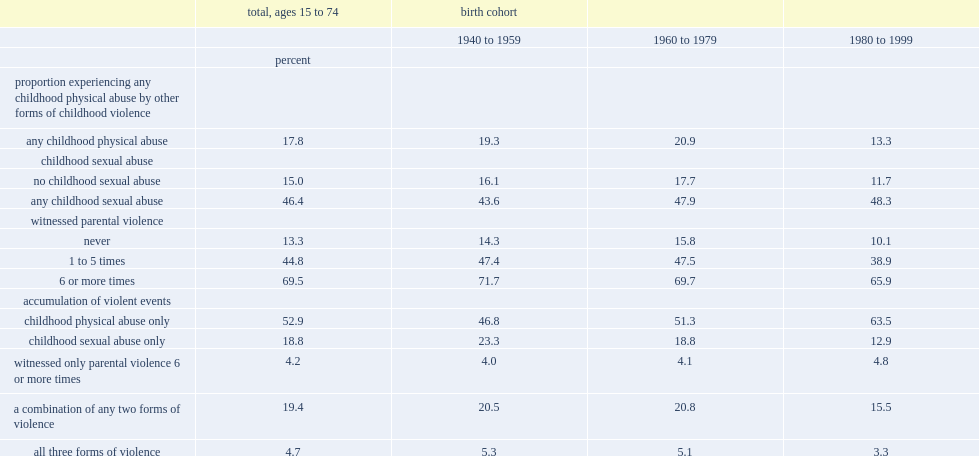What is the overall rate of childhood physical abuse across ages 15 to 74? 17.8. If the respondent had also experienced sexual abuse in childhood, what is the rate of physical abuse across ages 15 to 74? 46.4. For all individuals aged 15 to 74, what is the rate of experiencing physical abuse in childhood if they also witnessed parental violence at least six times? 69.5. Among those who said they witnessed parental violence between one and five times, how many percent of people would say they were victims of childhood physical abuse? 44.8. For those who witnessed no parental violence, how many percent of people would say they were victims of childhood physical abuse? 13.3. Among those aged 15 to 74 who said they had experienced any type of violence in childhood, how many percent of people would say it was physical abuse only? 52.9. Among those aged 15 to 74 who said they had experienced any type of violence in childhood, how many percent of people would say it was sexual abuse only? 18.8. Among those aged 15 to 74 who said they had experienced any type of violence in childhood, how many percent of people would say that they had witnessed frequent parental violence only? 4.2. Among those aged 15 to 74 who said they had experienced any type of violence in childhood, how many percent of people said that they had experienced any two of the three maltreatment factors? 19.4. Among those aged 15 to 74 who said they had experienced any type of violence in childhood, how many percent of people said they had experienced all three forms of violence? 4.7. 